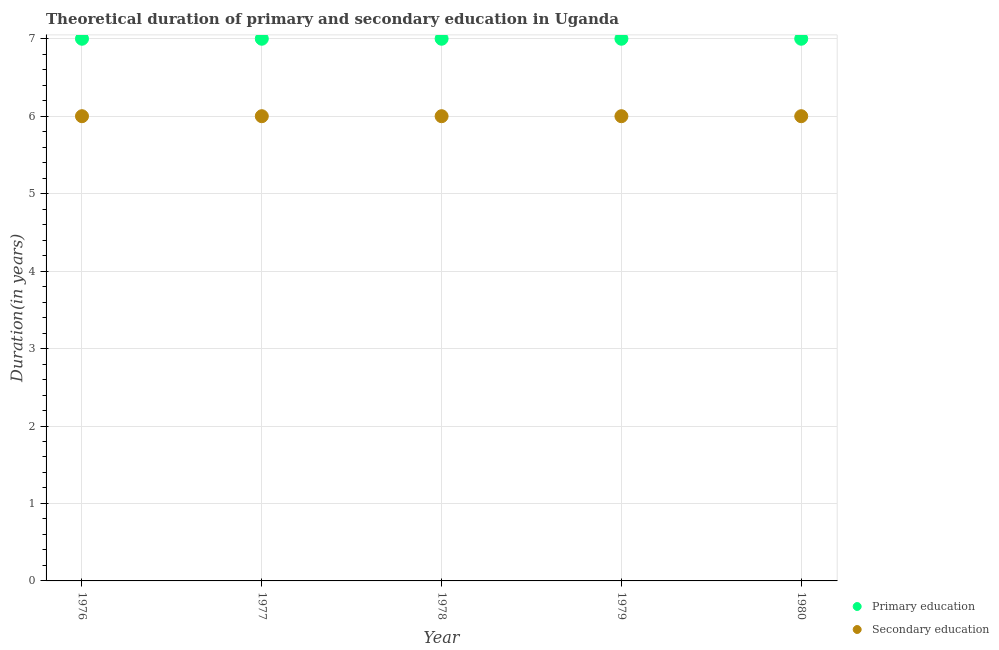How many different coloured dotlines are there?
Your response must be concise. 2. Is the number of dotlines equal to the number of legend labels?
Offer a very short reply. Yes. What is the duration of primary education in 1978?
Offer a very short reply. 7. Across all years, what is the maximum duration of primary education?
Keep it short and to the point. 7. Across all years, what is the minimum duration of primary education?
Keep it short and to the point. 7. In which year was the duration of secondary education maximum?
Make the answer very short. 1976. In which year was the duration of primary education minimum?
Your answer should be compact. 1976. What is the total duration of primary education in the graph?
Give a very brief answer. 35. What is the difference between the duration of secondary education in 1976 and that in 1980?
Offer a very short reply. 0. What is the difference between the duration of secondary education in 1980 and the duration of primary education in 1977?
Offer a terse response. -1. In the year 1980, what is the difference between the duration of primary education and duration of secondary education?
Ensure brevity in your answer.  1. Is the difference between the duration of primary education in 1977 and 1978 greater than the difference between the duration of secondary education in 1977 and 1978?
Provide a succinct answer. No. What is the difference between the highest and the lowest duration of secondary education?
Provide a short and direct response. 0. In how many years, is the duration of secondary education greater than the average duration of secondary education taken over all years?
Offer a very short reply. 0. Is the duration of primary education strictly greater than the duration of secondary education over the years?
Your answer should be compact. Yes. Are the values on the major ticks of Y-axis written in scientific E-notation?
Give a very brief answer. No. Does the graph contain any zero values?
Offer a terse response. No. What is the title of the graph?
Provide a short and direct response. Theoretical duration of primary and secondary education in Uganda. Does "Male" appear as one of the legend labels in the graph?
Ensure brevity in your answer.  No. What is the label or title of the X-axis?
Offer a very short reply. Year. What is the label or title of the Y-axis?
Keep it short and to the point. Duration(in years). What is the Duration(in years) of Secondary education in 1976?
Make the answer very short. 6. What is the Duration(in years) in Primary education in 1977?
Provide a succinct answer. 7. What is the Duration(in years) of Secondary education in 1979?
Ensure brevity in your answer.  6. What is the Duration(in years) in Primary education in 1980?
Your response must be concise. 7. What is the Duration(in years) in Secondary education in 1980?
Make the answer very short. 6. Across all years, what is the maximum Duration(in years) in Primary education?
Offer a terse response. 7. Across all years, what is the maximum Duration(in years) in Secondary education?
Ensure brevity in your answer.  6. Across all years, what is the minimum Duration(in years) of Primary education?
Your response must be concise. 7. What is the total Duration(in years) of Primary education in the graph?
Ensure brevity in your answer.  35. What is the difference between the Duration(in years) of Primary education in 1976 and that in 1977?
Offer a very short reply. 0. What is the difference between the Duration(in years) of Secondary education in 1976 and that in 1977?
Make the answer very short. 0. What is the difference between the Duration(in years) of Primary education in 1976 and that in 1978?
Give a very brief answer. 0. What is the difference between the Duration(in years) in Secondary education in 1976 and that in 1978?
Provide a succinct answer. 0. What is the difference between the Duration(in years) in Primary education in 1976 and that in 1979?
Your answer should be compact. 0. What is the difference between the Duration(in years) of Secondary education in 1976 and that in 1979?
Ensure brevity in your answer.  0. What is the difference between the Duration(in years) of Primary education in 1976 and that in 1980?
Ensure brevity in your answer.  0. What is the difference between the Duration(in years) of Secondary education in 1976 and that in 1980?
Your response must be concise. 0. What is the difference between the Duration(in years) of Primary education in 1977 and that in 1978?
Offer a terse response. 0. What is the difference between the Duration(in years) of Primary education in 1977 and that in 1979?
Your response must be concise. 0. What is the difference between the Duration(in years) in Secondary education in 1977 and that in 1979?
Your answer should be compact. 0. What is the difference between the Duration(in years) in Primary education in 1977 and that in 1980?
Ensure brevity in your answer.  0. What is the difference between the Duration(in years) of Primary education in 1978 and that in 1979?
Offer a terse response. 0. What is the difference between the Duration(in years) in Secondary education in 1978 and that in 1980?
Ensure brevity in your answer.  0. What is the difference between the Duration(in years) of Primary education in 1979 and that in 1980?
Provide a short and direct response. 0. What is the difference between the Duration(in years) in Primary education in 1976 and the Duration(in years) in Secondary education in 1978?
Give a very brief answer. 1. What is the difference between the Duration(in years) in Primary education in 1976 and the Duration(in years) in Secondary education in 1979?
Keep it short and to the point. 1. What is the difference between the Duration(in years) in Primary education in 1977 and the Duration(in years) in Secondary education in 1979?
Make the answer very short. 1. What is the difference between the Duration(in years) in Primary education in 1978 and the Duration(in years) in Secondary education in 1979?
Your answer should be compact. 1. What is the difference between the Duration(in years) of Primary education in 1978 and the Duration(in years) of Secondary education in 1980?
Ensure brevity in your answer.  1. What is the average Duration(in years) of Primary education per year?
Offer a terse response. 7. In the year 1976, what is the difference between the Duration(in years) in Primary education and Duration(in years) in Secondary education?
Make the answer very short. 1. In the year 1977, what is the difference between the Duration(in years) in Primary education and Duration(in years) in Secondary education?
Make the answer very short. 1. In the year 1980, what is the difference between the Duration(in years) in Primary education and Duration(in years) in Secondary education?
Ensure brevity in your answer.  1. What is the ratio of the Duration(in years) of Secondary education in 1976 to that in 1977?
Keep it short and to the point. 1. What is the ratio of the Duration(in years) in Primary education in 1976 to that in 1979?
Your answer should be very brief. 1. What is the ratio of the Duration(in years) of Primary education in 1976 to that in 1980?
Provide a short and direct response. 1. What is the ratio of the Duration(in years) in Secondary education in 1977 to that in 1979?
Your answer should be compact. 1. What is the ratio of the Duration(in years) of Primary education in 1978 to that in 1979?
Keep it short and to the point. 1. What is the ratio of the Duration(in years) of Secondary education in 1979 to that in 1980?
Make the answer very short. 1. What is the difference between the highest and the second highest Duration(in years) of Primary education?
Your response must be concise. 0. 